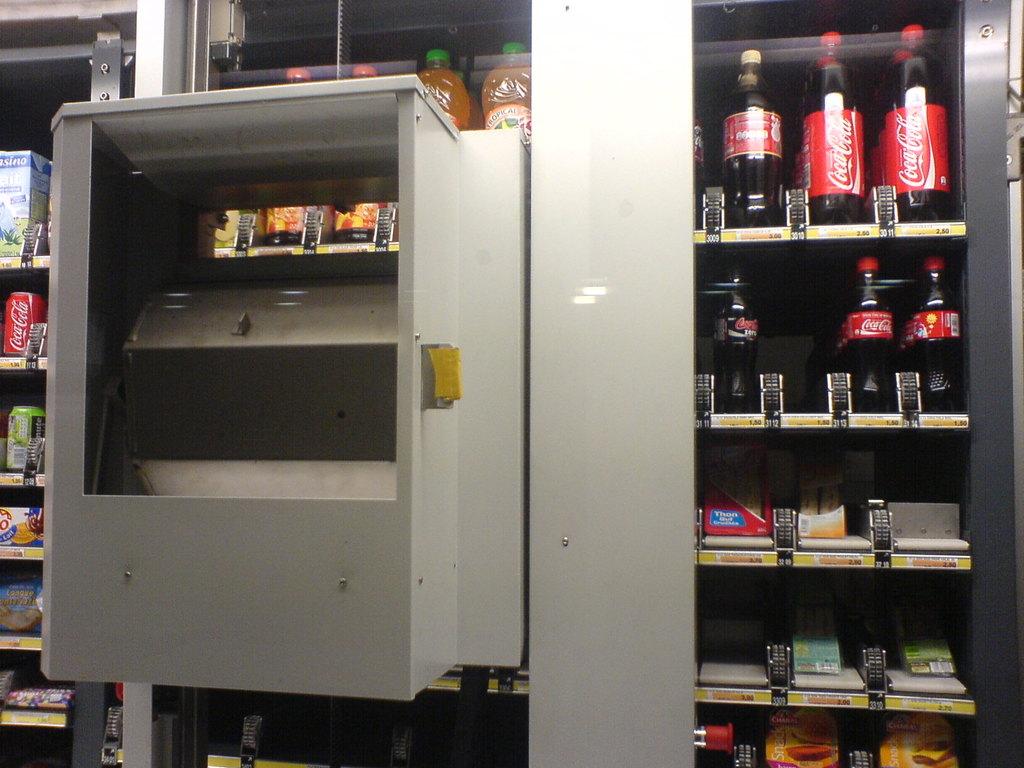What kind of drink is displayed on the top right?
Your answer should be compact. Coca-cola. What´s the brand of the soda?
Keep it short and to the point. Coca cola. 